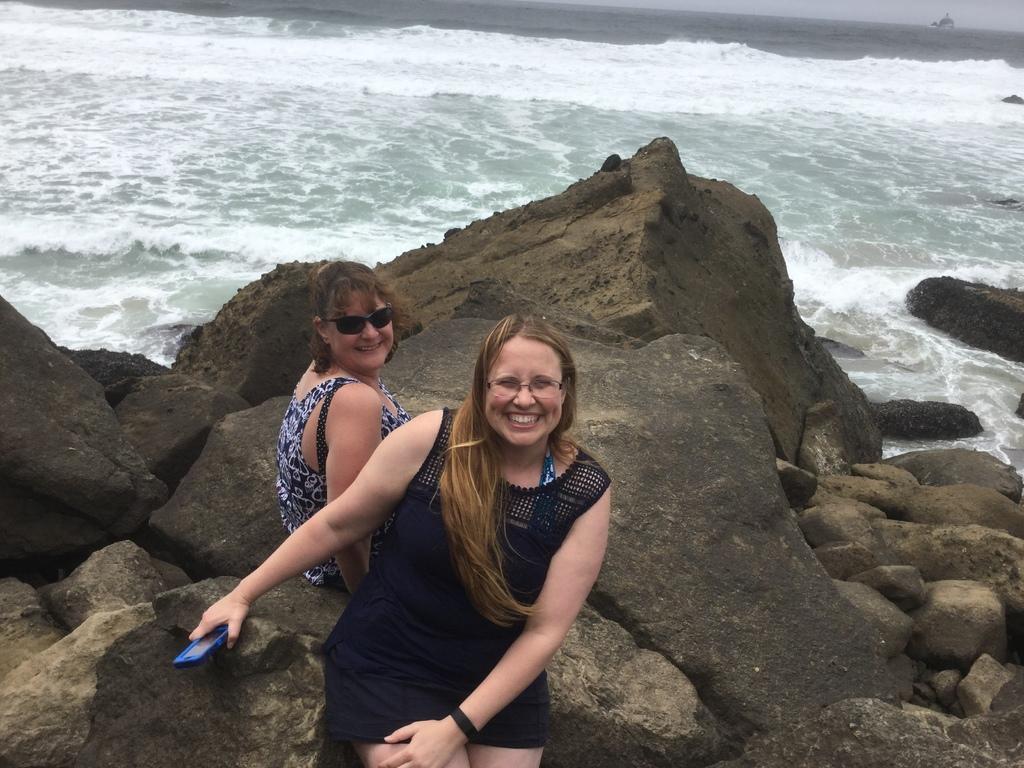Could you give a brief overview of what you see in this image? In this picture I can see two women with a smile sitting on the surface. I can see the rocks. I can see water. 